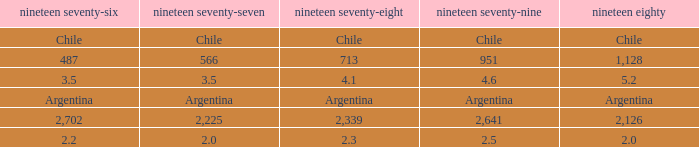What is 1976 when 1977 is 3.5? 3.5. 